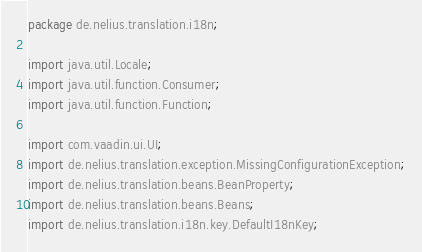Convert code to text. <code><loc_0><loc_0><loc_500><loc_500><_Java_>package de.nelius.translation.i18n;

import java.util.Locale;
import java.util.function.Consumer;
import java.util.function.Function;

import com.vaadin.ui.UI;
import de.nelius.translation.exception.MissingConfigurationException;
import de.nelius.translation.beans.BeanProperty;
import de.nelius.translation.beans.Beans;
import de.nelius.translation.i18n.key.DefaultI18nKey;</code> 